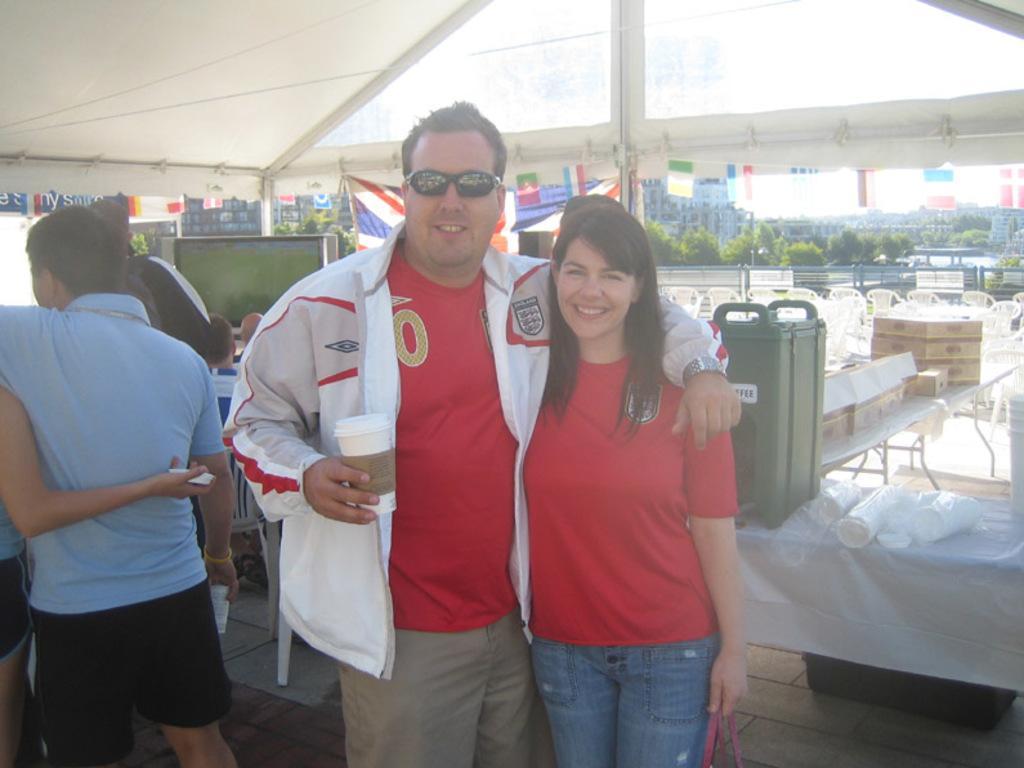Could you give a brief overview of what you see in this image? In this image there is a man and a woman standing with a smile on their face, the man is holding a cup, the woman is holding a bag, beside them there is a couple standing, behind them there are a few objects on the tables and there are a few people seated in chairs are watching television under a tent, in the background of the image there are empty chairs, trees, flags and buildings. 